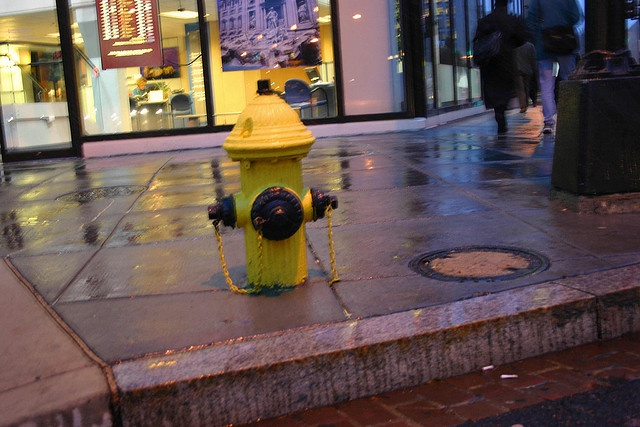Describe the objects in this image and their specific colors. I can see fire hydrant in lightgray, olive, black, and orange tones, people in lightgray, black, navy, and purple tones, people in lightgray, black, navy, gray, and darkblue tones, people in lightgray, black, and gray tones, and chair in lightgray, black, navy, gray, and darkgray tones in this image. 